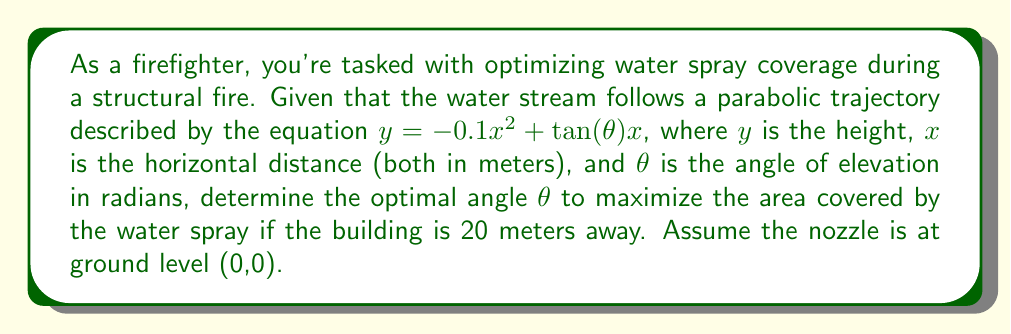Help me with this question. 1) The parabolic trajectory is given by $y = -0.1x^2 + \tan(\theta)x$

2) To find the maximum height, we differentiate y with respect to x:
   $\frac{dy}{dx} = -0.2x + \tan(\theta)$

3) Set this equal to zero to find the x-coordinate of the vertex:
   $-0.2x + \tan(\theta) = 0$
   $x = 5\tan(\theta)$

4) The maximum height occurs at this x-value. Substitute back into the original equation:
   $y_{max} = -0.1(5\tan(\theta))^2 + \tan(\theta)(5\tan(\theta))$
   $y_{max} = -2.5\tan^2(\theta) + 5\tan^2(\theta) = 2.5\tan^2(\theta)$

5) For maximum coverage, we want this height to occur at x = 20 (the building's distance):
   $20 = 5\tan(\theta)$
   $\tan(\theta) = 4$

6) Taking the inverse tangent of both sides:
   $\theta = \arctan(4)$

7) Convert to degrees:
   $\theta \approx 75.96°$
Answer: $\theta \approx 75.96°$ 